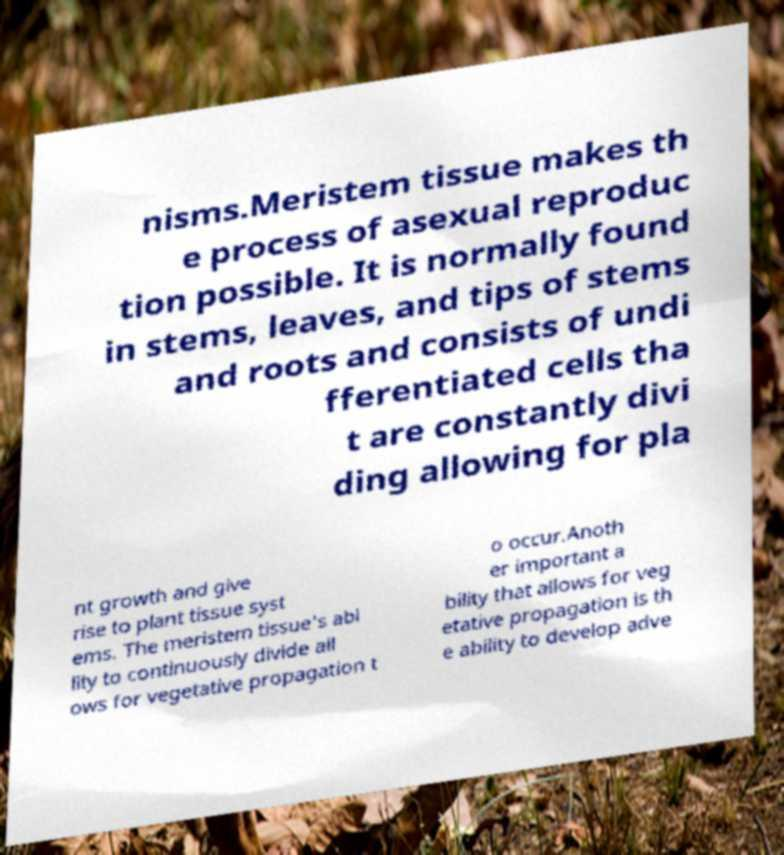I need the written content from this picture converted into text. Can you do that? nisms.Meristem tissue makes th e process of asexual reproduc tion possible. It is normally found in stems, leaves, and tips of stems and roots and consists of undi fferentiated cells tha t are constantly divi ding allowing for pla nt growth and give rise to plant tissue syst ems. The meristem tissue's abi lity to continuously divide all ows for vegetative propagation t o occur.Anoth er important a bility that allows for veg etative propagation is th e ability to develop adve 